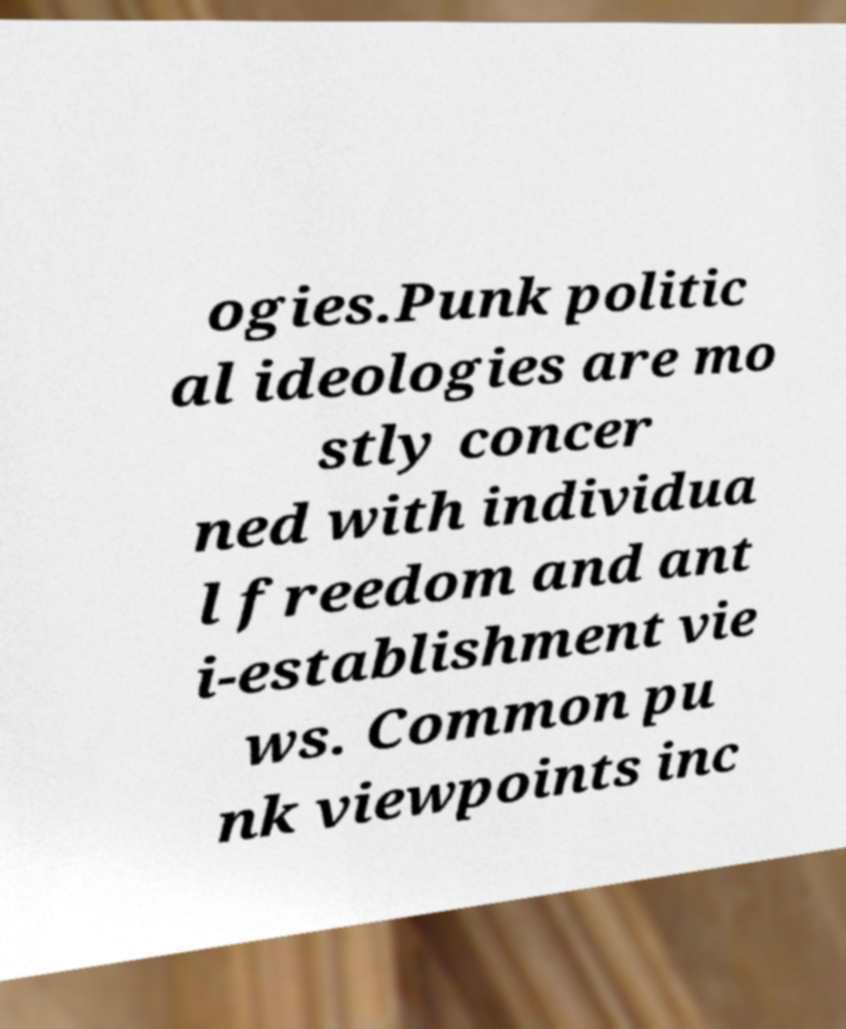Please identify and transcribe the text found in this image. ogies.Punk politic al ideologies are mo stly concer ned with individua l freedom and ant i-establishment vie ws. Common pu nk viewpoints inc 